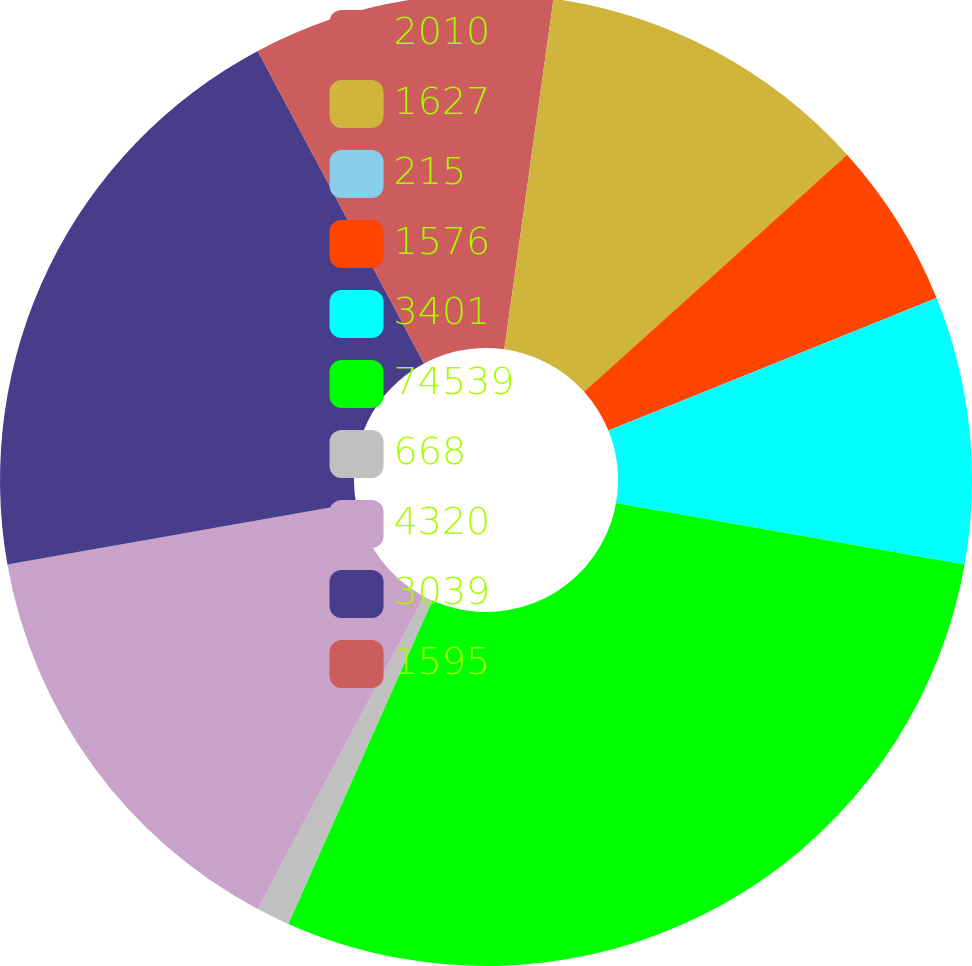<chart> <loc_0><loc_0><loc_500><loc_500><pie_chart><fcel>2010<fcel>1627<fcel>215<fcel>1576<fcel>3401<fcel>74539<fcel>668<fcel>4320<fcel>3039<fcel>1595<nl><fcel>2.22%<fcel>11.11%<fcel>0.0%<fcel>5.56%<fcel>8.89%<fcel>28.89%<fcel>1.11%<fcel>14.44%<fcel>20.0%<fcel>7.78%<nl></chart> 